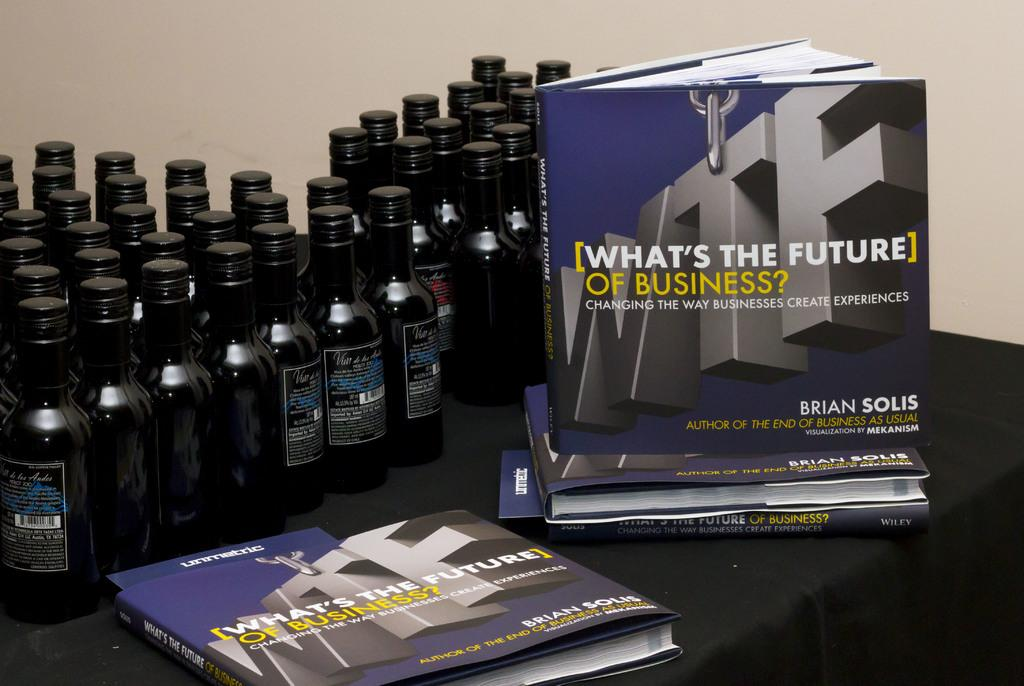Provide a one-sentence caption for the provided image. Many bottles sit next to a book titled What. 